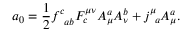Convert formula to latex. <formula><loc_0><loc_0><loc_500><loc_500>a _ { 0 } = \frac { 1 } { 2 } f _ { \, a b } ^ { c } F _ { c } ^ { \mu \nu } A _ { \mu } ^ { a } A _ { \nu } ^ { b } + j _ { \, a } ^ { \mu } A _ { \mu } ^ { a } .</formula> 